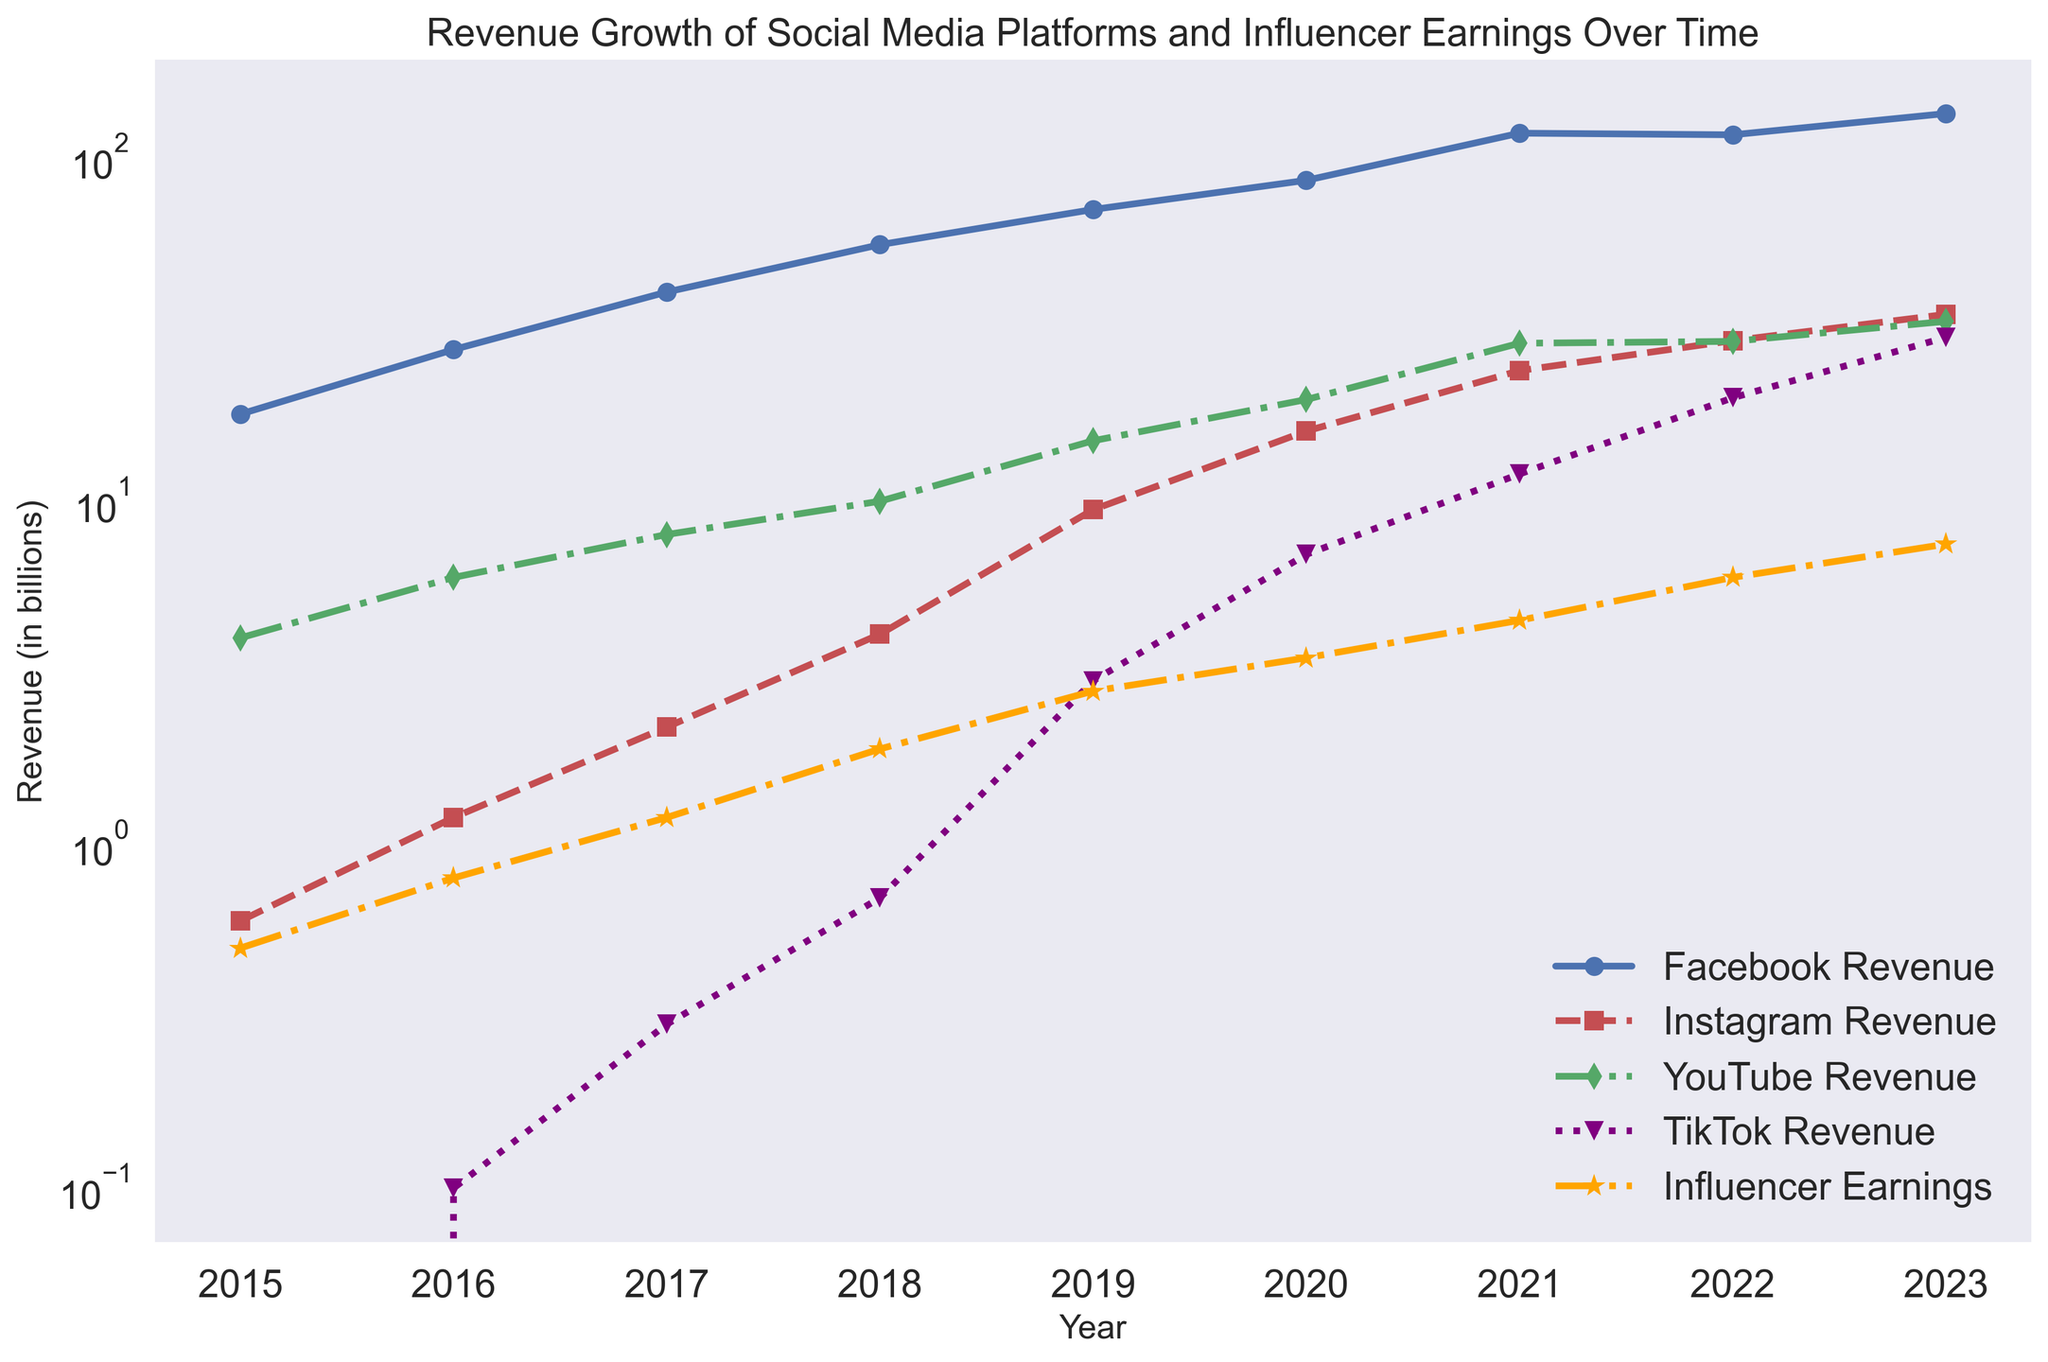Which platform had the highest revenue in 2020? Look at the revenue values for all platforms in 2020. Facebook's revenue is the highest among all shown figures.
Answer: Facebook Which year did TikTok's revenue start to accelerate noticeably? Compare the revenues of TikTok across the years. Noticeable acceleration starts in 2019 when the value jumps significantly compared to previous years.
Answer: 2019 How does the growth of influencer earnings from 2015 to 2018 compare to the growth from 2021 to 2023? Calculate the growth: From 2015 to 2018, earnings went from 0.5 to 1.9 (1.9 - 0.5 = 1.4). From 2021 to 2023, earnings went from 4.5 to 7.5 (7.5 - 4.5 = 3.0). The latter period had more substantial growth.
Answer: Greater in 2021-2023 Which platform exhibited the most consistent growth in revenue over the years? Evaluate the revenue patterns for each platform. Facebook's revenue shows a smooth and consistent upward trend from 2015 to 2023.
Answer: Facebook What is the total combined revenue of all platforms in 2015? Sum the revenues for all platforms in 2015: Facebook (17.93) + Instagram (0.6) + YouTube (4) + TikTok (0) = 22.53 billion.
Answer: 22.53 billion Between 2017 and 2022, which platform had the highest revenue growth rate? Calculate growth rates: Facebook (116.64 - 40.65 = 76.99), Instagram (29.35 - 2.2 = 27.15), YouTube (29.2 - 8 = 21.2), TikTok (20 - 0.3 = 19.7). Facebook has the highest increase.
Answer: Facebook For which year did the growth of influencer earnings surpass $3 billion? Compare influencer earnings year by year; it first surpasses $3 billion in 2020.
Answer: 2020 How does the revenue trend of Instagram compare to Facebook's trend? Visually examine both lines. Instagram shows a steeper upward trend compared to Facebook, indicating a faster growth rate, particularly from 2017 onward.
Answer: Steeper for Instagram Which platform's revenue was equal to TikTok's revenue in 2022? Check the revenues in 2022: TikTok (20B) matches YouTube (29.2) approximately.
Answer: YouTube What’s the average revenue of YouTube from 2017 to 2021? Calculate YouTube’s revenues from 2017 to 2021: (8 + 10 + 15 + 19.77+ 28.84) / 5 = 16.322 billion.
Answer: 16.322 billion 